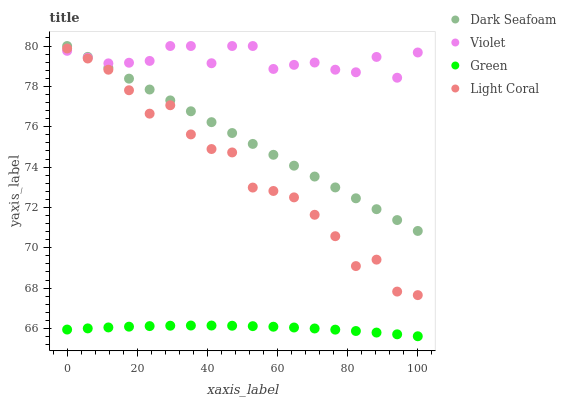Does Green have the minimum area under the curve?
Answer yes or no. Yes. Does Violet have the maximum area under the curve?
Answer yes or no. Yes. Does Dark Seafoam have the minimum area under the curve?
Answer yes or no. No. Does Dark Seafoam have the maximum area under the curve?
Answer yes or no. No. Is Dark Seafoam the smoothest?
Answer yes or no. Yes. Is Light Coral the roughest?
Answer yes or no. Yes. Is Green the smoothest?
Answer yes or no. No. Is Green the roughest?
Answer yes or no. No. Does Green have the lowest value?
Answer yes or no. Yes. Does Dark Seafoam have the lowest value?
Answer yes or no. No. Does Violet have the highest value?
Answer yes or no. Yes. Does Green have the highest value?
Answer yes or no. No. Is Light Coral less than Dark Seafoam?
Answer yes or no. Yes. Is Dark Seafoam greater than Light Coral?
Answer yes or no. Yes. Does Dark Seafoam intersect Violet?
Answer yes or no. Yes. Is Dark Seafoam less than Violet?
Answer yes or no. No. Is Dark Seafoam greater than Violet?
Answer yes or no. No. Does Light Coral intersect Dark Seafoam?
Answer yes or no. No. 